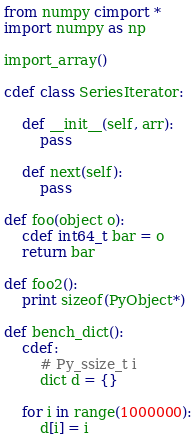<code> <loc_0><loc_0><loc_500><loc_500><_Cython_>from numpy cimport *
import numpy as np

import_array()

cdef class SeriesIterator:

    def __init__(self, arr):
        pass

    def next(self):
        pass

def foo(object o):
    cdef int64_t bar = o
    return bar

def foo2():
    print sizeof(PyObject*)

def bench_dict():
    cdef:
        # Py_ssize_t i
        dict d = {}

    for i in range(1000000):
        d[i] = i
</code> 